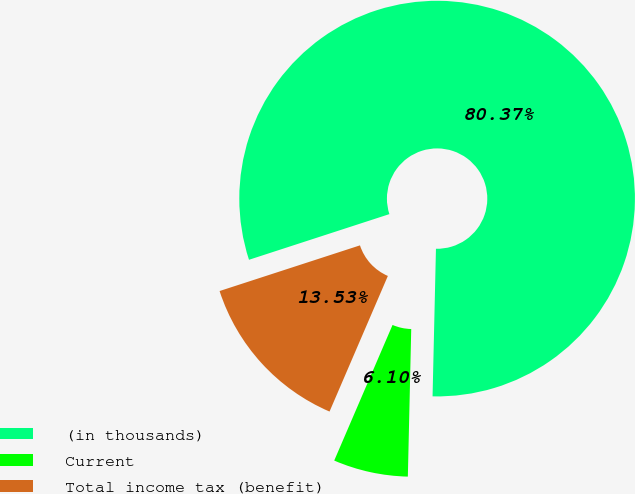<chart> <loc_0><loc_0><loc_500><loc_500><pie_chart><fcel>(in thousands)<fcel>Current<fcel>Total income tax (benefit)<nl><fcel>80.37%<fcel>6.1%<fcel>13.53%<nl></chart> 